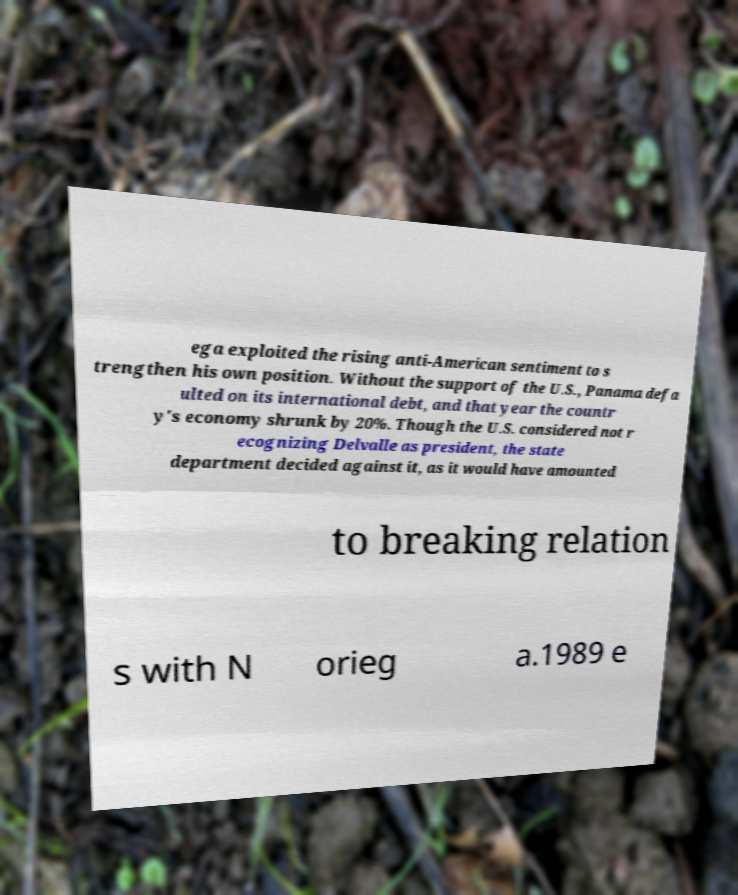I need the written content from this picture converted into text. Can you do that? ega exploited the rising anti-American sentiment to s trengthen his own position. Without the support of the U.S., Panama defa ulted on its international debt, and that year the countr y's economy shrunk by 20%. Though the U.S. considered not r ecognizing Delvalle as president, the state department decided against it, as it would have amounted to breaking relation s with N orieg a.1989 e 